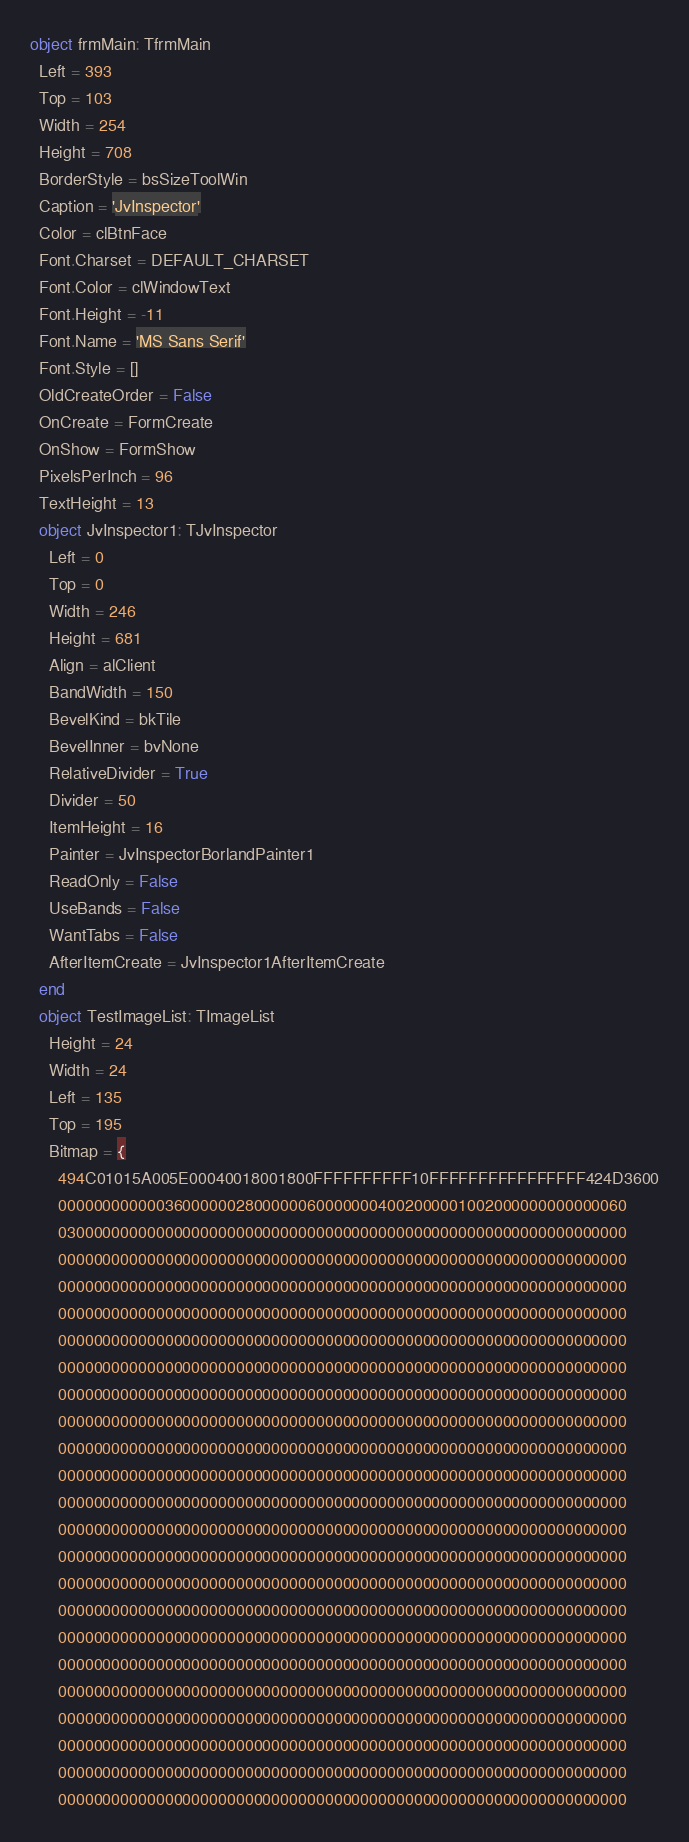<code> <loc_0><loc_0><loc_500><loc_500><_Pascal_>object frmMain: TfrmMain
  Left = 393
  Top = 103
  Width = 254
  Height = 708
  BorderStyle = bsSizeToolWin
  Caption = 'JvInspector'
  Color = clBtnFace
  Font.Charset = DEFAULT_CHARSET
  Font.Color = clWindowText
  Font.Height = -11
  Font.Name = 'MS Sans Serif'
  Font.Style = []
  OldCreateOrder = False
  OnCreate = FormCreate
  OnShow = FormShow
  PixelsPerInch = 96
  TextHeight = 13
  object JvInspector1: TJvInspector
    Left = 0
    Top = 0
    Width = 246
    Height = 681
    Align = alClient
    BandWidth = 150
    BevelKind = bkTile
    BevelInner = bvNone
    RelativeDivider = True
    Divider = 50
    ItemHeight = 16
    Painter = JvInspectorBorlandPainter1
    ReadOnly = False
    UseBands = False
    WantTabs = False
    AfterItemCreate = JvInspector1AfterItemCreate
  end
  object TestImageList: TImageList
    Height = 24
    Width = 24
    Left = 135
    Top = 195
    Bitmap = {
      494C01015A005E00040018001800FFFFFFFFFF10FFFFFFFFFFFFFFFF424D3600
      0000000000003600000028000000600000004002000001002000000000000060
      0300000000000000000000000000000000000000000000000000000000000000
      0000000000000000000000000000000000000000000000000000000000000000
      0000000000000000000000000000000000000000000000000000000000000000
      0000000000000000000000000000000000000000000000000000000000000000
      0000000000000000000000000000000000000000000000000000000000000000
      0000000000000000000000000000000000000000000000000000000000000000
      0000000000000000000000000000000000000000000000000000000000000000
      0000000000000000000000000000000000000000000000000000000000000000
      0000000000000000000000000000000000000000000000000000000000000000
      0000000000000000000000000000000000000000000000000000000000000000
      0000000000000000000000000000000000000000000000000000000000000000
      0000000000000000000000000000000000000000000000000000000000000000
      0000000000000000000000000000000000000000000000000000000000000000
      0000000000000000000000000000000000000000000000000000000000000000
      0000000000000000000000000000000000000000000000000000000000000000
      0000000000000000000000000000000000000000000000000000000000000000
      0000000000000000000000000000000000000000000000000000000000000000
      0000000000000000000000000000000000000000000000000000000000000000
      0000000000000000000000000000000000000000000000000000000000000000
      0000000000000000000000000000000000000000000000000000000000000000
      0000000000000000000000000000000000000000000000000000000000000000
      0000000000000000000000000000000000000000000000000000000000000000</code> 